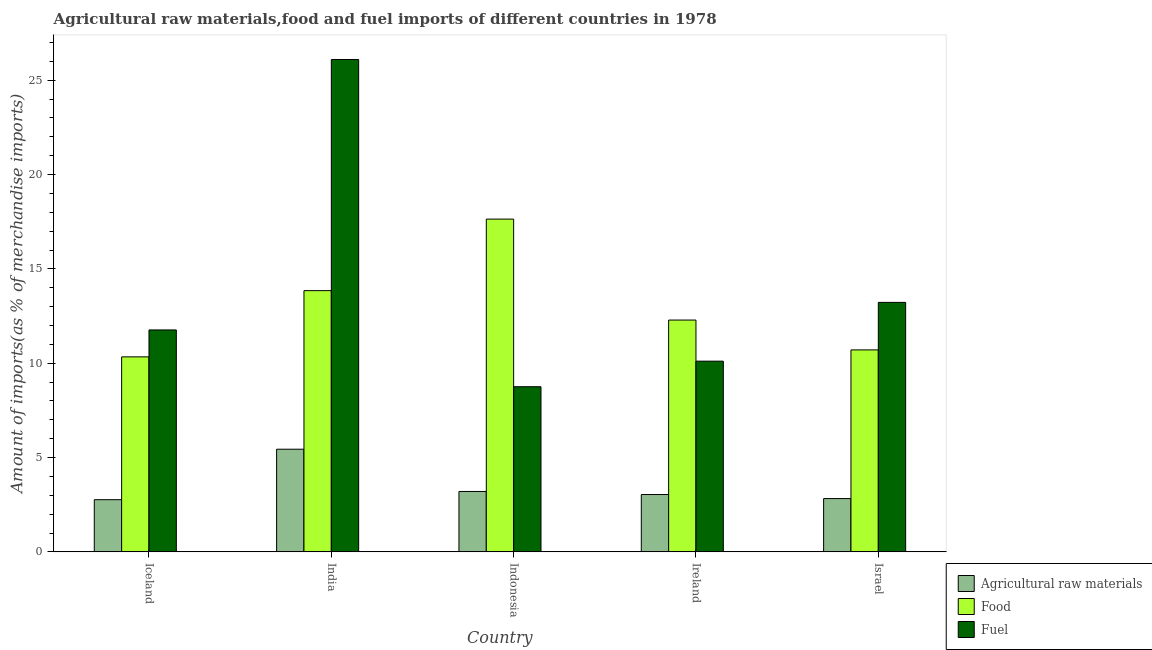Are the number of bars per tick equal to the number of legend labels?
Your answer should be very brief. Yes. Are the number of bars on each tick of the X-axis equal?
Keep it short and to the point. Yes. How many bars are there on the 5th tick from the left?
Provide a short and direct response. 3. How many bars are there on the 1st tick from the right?
Ensure brevity in your answer.  3. What is the label of the 4th group of bars from the left?
Ensure brevity in your answer.  Ireland. In how many cases, is the number of bars for a given country not equal to the number of legend labels?
Keep it short and to the point. 0. What is the percentage of food imports in India?
Offer a very short reply. 13.85. Across all countries, what is the maximum percentage of raw materials imports?
Make the answer very short. 5.44. Across all countries, what is the minimum percentage of fuel imports?
Make the answer very short. 8.75. What is the total percentage of food imports in the graph?
Give a very brief answer. 64.81. What is the difference between the percentage of fuel imports in India and that in Ireland?
Provide a succinct answer. 15.99. What is the difference between the percentage of raw materials imports in Iceland and the percentage of fuel imports in Ireland?
Your answer should be very brief. -7.34. What is the average percentage of food imports per country?
Offer a very short reply. 12.96. What is the difference between the percentage of raw materials imports and percentage of food imports in Iceland?
Provide a succinct answer. -7.57. In how many countries, is the percentage of raw materials imports greater than 10 %?
Offer a terse response. 0. What is the ratio of the percentage of raw materials imports in India to that in Israel?
Your response must be concise. 1.93. Is the percentage of fuel imports in Iceland less than that in India?
Provide a short and direct response. Yes. Is the difference between the percentage of fuel imports in India and Israel greater than the difference between the percentage of raw materials imports in India and Israel?
Give a very brief answer. Yes. What is the difference between the highest and the second highest percentage of fuel imports?
Offer a terse response. 12.87. What is the difference between the highest and the lowest percentage of raw materials imports?
Provide a succinct answer. 2.68. In how many countries, is the percentage of fuel imports greater than the average percentage of fuel imports taken over all countries?
Your answer should be very brief. 1. Is the sum of the percentage of fuel imports in Iceland and Israel greater than the maximum percentage of food imports across all countries?
Offer a very short reply. Yes. What does the 1st bar from the left in Indonesia represents?
Give a very brief answer. Agricultural raw materials. What does the 3rd bar from the right in India represents?
Give a very brief answer. Agricultural raw materials. Are all the bars in the graph horizontal?
Your answer should be compact. No. How many countries are there in the graph?
Offer a very short reply. 5. What is the difference between two consecutive major ticks on the Y-axis?
Your answer should be very brief. 5. Are the values on the major ticks of Y-axis written in scientific E-notation?
Your answer should be very brief. No. Does the graph contain any zero values?
Your response must be concise. No. Does the graph contain grids?
Your answer should be very brief. No. How many legend labels are there?
Provide a succinct answer. 3. What is the title of the graph?
Ensure brevity in your answer.  Agricultural raw materials,food and fuel imports of different countries in 1978. What is the label or title of the Y-axis?
Provide a succinct answer. Amount of imports(as % of merchandise imports). What is the Amount of imports(as % of merchandise imports) of Agricultural raw materials in Iceland?
Offer a terse response. 2.77. What is the Amount of imports(as % of merchandise imports) of Food in Iceland?
Make the answer very short. 10.34. What is the Amount of imports(as % of merchandise imports) in Fuel in Iceland?
Your response must be concise. 11.76. What is the Amount of imports(as % of merchandise imports) in Agricultural raw materials in India?
Provide a succinct answer. 5.44. What is the Amount of imports(as % of merchandise imports) of Food in India?
Keep it short and to the point. 13.85. What is the Amount of imports(as % of merchandise imports) in Fuel in India?
Offer a very short reply. 26.1. What is the Amount of imports(as % of merchandise imports) of Agricultural raw materials in Indonesia?
Your response must be concise. 3.2. What is the Amount of imports(as % of merchandise imports) in Food in Indonesia?
Offer a very short reply. 17.64. What is the Amount of imports(as % of merchandise imports) in Fuel in Indonesia?
Offer a terse response. 8.75. What is the Amount of imports(as % of merchandise imports) in Agricultural raw materials in Ireland?
Keep it short and to the point. 3.04. What is the Amount of imports(as % of merchandise imports) in Food in Ireland?
Provide a succinct answer. 12.29. What is the Amount of imports(as % of merchandise imports) of Fuel in Ireland?
Provide a short and direct response. 10.11. What is the Amount of imports(as % of merchandise imports) in Agricultural raw materials in Israel?
Provide a succinct answer. 2.82. What is the Amount of imports(as % of merchandise imports) of Food in Israel?
Keep it short and to the point. 10.71. What is the Amount of imports(as % of merchandise imports) in Fuel in Israel?
Ensure brevity in your answer.  13.22. Across all countries, what is the maximum Amount of imports(as % of merchandise imports) in Agricultural raw materials?
Provide a short and direct response. 5.44. Across all countries, what is the maximum Amount of imports(as % of merchandise imports) of Food?
Ensure brevity in your answer.  17.64. Across all countries, what is the maximum Amount of imports(as % of merchandise imports) in Fuel?
Keep it short and to the point. 26.1. Across all countries, what is the minimum Amount of imports(as % of merchandise imports) in Agricultural raw materials?
Offer a terse response. 2.77. Across all countries, what is the minimum Amount of imports(as % of merchandise imports) of Food?
Keep it short and to the point. 10.34. Across all countries, what is the minimum Amount of imports(as % of merchandise imports) of Fuel?
Give a very brief answer. 8.75. What is the total Amount of imports(as % of merchandise imports) in Agricultural raw materials in the graph?
Ensure brevity in your answer.  17.27. What is the total Amount of imports(as % of merchandise imports) of Food in the graph?
Offer a terse response. 64.81. What is the total Amount of imports(as % of merchandise imports) in Fuel in the graph?
Make the answer very short. 69.95. What is the difference between the Amount of imports(as % of merchandise imports) in Agricultural raw materials in Iceland and that in India?
Make the answer very short. -2.68. What is the difference between the Amount of imports(as % of merchandise imports) in Food in Iceland and that in India?
Provide a succinct answer. -3.51. What is the difference between the Amount of imports(as % of merchandise imports) of Fuel in Iceland and that in India?
Offer a very short reply. -14.33. What is the difference between the Amount of imports(as % of merchandise imports) in Agricultural raw materials in Iceland and that in Indonesia?
Your answer should be very brief. -0.44. What is the difference between the Amount of imports(as % of merchandise imports) of Food in Iceland and that in Indonesia?
Your response must be concise. -7.3. What is the difference between the Amount of imports(as % of merchandise imports) in Fuel in Iceland and that in Indonesia?
Your answer should be very brief. 3.01. What is the difference between the Amount of imports(as % of merchandise imports) in Agricultural raw materials in Iceland and that in Ireland?
Give a very brief answer. -0.27. What is the difference between the Amount of imports(as % of merchandise imports) of Food in Iceland and that in Ireland?
Give a very brief answer. -1.95. What is the difference between the Amount of imports(as % of merchandise imports) of Fuel in Iceland and that in Ireland?
Ensure brevity in your answer.  1.66. What is the difference between the Amount of imports(as % of merchandise imports) of Agricultural raw materials in Iceland and that in Israel?
Your response must be concise. -0.06. What is the difference between the Amount of imports(as % of merchandise imports) of Food in Iceland and that in Israel?
Ensure brevity in your answer.  -0.37. What is the difference between the Amount of imports(as % of merchandise imports) of Fuel in Iceland and that in Israel?
Your response must be concise. -1.46. What is the difference between the Amount of imports(as % of merchandise imports) in Agricultural raw materials in India and that in Indonesia?
Give a very brief answer. 2.24. What is the difference between the Amount of imports(as % of merchandise imports) of Food in India and that in Indonesia?
Make the answer very short. -3.79. What is the difference between the Amount of imports(as % of merchandise imports) of Fuel in India and that in Indonesia?
Provide a short and direct response. 17.34. What is the difference between the Amount of imports(as % of merchandise imports) in Agricultural raw materials in India and that in Ireland?
Keep it short and to the point. 2.4. What is the difference between the Amount of imports(as % of merchandise imports) of Food in India and that in Ireland?
Give a very brief answer. 1.56. What is the difference between the Amount of imports(as % of merchandise imports) of Fuel in India and that in Ireland?
Provide a succinct answer. 15.99. What is the difference between the Amount of imports(as % of merchandise imports) in Agricultural raw materials in India and that in Israel?
Ensure brevity in your answer.  2.62. What is the difference between the Amount of imports(as % of merchandise imports) in Food in India and that in Israel?
Provide a short and direct response. 3.14. What is the difference between the Amount of imports(as % of merchandise imports) in Fuel in India and that in Israel?
Ensure brevity in your answer.  12.87. What is the difference between the Amount of imports(as % of merchandise imports) of Agricultural raw materials in Indonesia and that in Ireland?
Give a very brief answer. 0.16. What is the difference between the Amount of imports(as % of merchandise imports) in Food in Indonesia and that in Ireland?
Offer a terse response. 5.35. What is the difference between the Amount of imports(as % of merchandise imports) of Fuel in Indonesia and that in Ireland?
Make the answer very short. -1.35. What is the difference between the Amount of imports(as % of merchandise imports) in Agricultural raw materials in Indonesia and that in Israel?
Make the answer very short. 0.38. What is the difference between the Amount of imports(as % of merchandise imports) in Food in Indonesia and that in Israel?
Give a very brief answer. 6.93. What is the difference between the Amount of imports(as % of merchandise imports) in Fuel in Indonesia and that in Israel?
Your response must be concise. -4.47. What is the difference between the Amount of imports(as % of merchandise imports) of Agricultural raw materials in Ireland and that in Israel?
Provide a short and direct response. 0.22. What is the difference between the Amount of imports(as % of merchandise imports) in Food in Ireland and that in Israel?
Ensure brevity in your answer.  1.58. What is the difference between the Amount of imports(as % of merchandise imports) in Fuel in Ireland and that in Israel?
Offer a terse response. -3.12. What is the difference between the Amount of imports(as % of merchandise imports) in Agricultural raw materials in Iceland and the Amount of imports(as % of merchandise imports) in Food in India?
Your answer should be very brief. -11.08. What is the difference between the Amount of imports(as % of merchandise imports) of Agricultural raw materials in Iceland and the Amount of imports(as % of merchandise imports) of Fuel in India?
Offer a very short reply. -23.33. What is the difference between the Amount of imports(as % of merchandise imports) of Food in Iceland and the Amount of imports(as % of merchandise imports) of Fuel in India?
Your response must be concise. -15.76. What is the difference between the Amount of imports(as % of merchandise imports) in Agricultural raw materials in Iceland and the Amount of imports(as % of merchandise imports) in Food in Indonesia?
Ensure brevity in your answer.  -14.87. What is the difference between the Amount of imports(as % of merchandise imports) in Agricultural raw materials in Iceland and the Amount of imports(as % of merchandise imports) in Fuel in Indonesia?
Your response must be concise. -5.99. What is the difference between the Amount of imports(as % of merchandise imports) in Food in Iceland and the Amount of imports(as % of merchandise imports) in Fuel in Indonesia?
Your answer should be compact. 1.58. What is the difference between the Amount of imports(as % of merchandise imports) in Agricultural raw materials in Iceland and the Amount of imports(as % of merchandise imports) in Food in Ireland?
Your answer should be very brief. -9.52. What is the difference between the Amount of imports(as % of merchandise imports) of Agricultural raw materials in Iceland and the Amount of imports(as % of merchandise imports) of Fuel in Ireland?
Keep it short and to the point. -7.34. What is the difference between the Amount of imports(as % of merchandise imports) in Food in Iceland and the Amount of imports(as % of merchandise imports) in Fuel in Ireland?
Make the answer very short. 0.23. What is the difference between the Amount of imports(as % of merchandise imports) in Agricultural raw materials in Iceland and the Amount of imports(as % of merchandise imports) in Food in Israel?
Make the answer very short. -7.94. What is the difference between the Amount of imports(as % of merchandise imports) of Agricultural raw materials in Iceland and the Amount of imports(as % of merchandise imports) of Fuel in Israel?
Ensure brevity in your answer.  -10.46. What is the difference between the Amount of imports(as % of merchandise imports) in Food in Iceland and the Amount of imports(as % of merchandise imports) in Fuel in Israel?
Keep it short and to the point. -2.89. What is the difference between the Amount of imports(as % of merchandise imports) in Agricultural raw materials in India and the Amount of imports(as % of merchandise imports) in Food in Indonesia?
Offer a very short reply. -12.2. What is the difference between the Amount of imports(as % of merchandise imports) in Agricultural raw materials in India and the Amount of imports(as % of merchandise imports) in Fuel in Indonesia?
Make the answer very short. -3.31. What is the difference between the Amount of imports(as % of merchandise imports) in Food in India and the Amount of imports(as % of merchandise imports) in Fuel in Indonesia?
Your response must be concise. 5.09. What is the difference between the Amount of imports(as % of merchandise imports) in Agricultural raw materials in India and the Amount of imports(as % of merchandise imports) in Food in Ireland?
Your answer should be very brief. -6.85. What is the difference between the Amount of imports(as % of merchandise imports) of Agricultural raw materials in India and the Amount of imports(as % of merchandise imports) of Fuel in Ireland?
Provide a short and direct response. -4.67. What is the difference between the Amount of imports(as % of merchandise imports) in Food in India and the Amount of imports(as % of merchandise imports) in Fuel in Ireland?
Offer a terse response. 3.74. What is the difference between the Amount of imports(as % of merchandise imports) in Agricultural raw materials in India and the Amount of imports(as % of merchandise imports) in Food in Israel?
Provide a short and direct response. -5.26. What is the difference between the Amount of imports(as % of merchandise imports) in Agricultural raw materials in India and the Amount of imports(as % of merchandise imports) in Fuel in Israel?
Keep it short and to the point. -7.78. What is the difference between the Amount of imports(as % of merchandise imports) of Food in India and the Amount of imports(as % of merchandise imports) of Fuel in Israel?
Provide a short and direct response. 0.62. What is the difference between the Amount of imports(as % of merchandise imports) of Agricultural raw materials in Indonesia and the Amount of imports(as % of merchandise imports) of Food in Ireland?
Provide a short and direct response. -9.08. What is the difference between the Amount of imports(as % of merchandise imports) in Agricultural raw materials in Indonesia and the Amount of imports(as % of merchandise imports) in Fuel in Ireland?
Keep it short and to the point. -6.91. What is the difference between the Amount of imports(as % of merchandise imports) in Food in Indonesia and the Amount of imports(as % of merchandise imports) in Fuel in Ireland?
Your answer should be compact. 7.53. What is the difference between the Amount of imports(as % of merchandise imports) in Agricultural raw materials in Indonesia and the Amount of imports(as % of merchandise imports) in Food in Israel?
Offer a terse response. -7.5. What is the difference between the Amount of imports(as % of merchandise imports) in Agricultural raw materials in Indonesia and the Amount of imports(as % of merchandise imports) in Fuel in Israel?
Provide a succinct answer. -10.02. What is the difference between the Amount of imports(as % of merchandise imports) in Food in Indonesia and the Amount of imports(as % of merchandise imports) in Fuel in Israel?
Keep it short and to the point. 4.41. What is the difference between the Amount of imports(as % of merchandise imports) in Agricultural raw materials in Ireland and the Amount of imports(as % of merchandise imports) in Food in Israel?
Offer a terse response. -7.67. What is the difference between the Amount of imports(as % of merchandise imports) of Agricultural raw materials in Ireland and the Amount of imports(as % of merchandise imports) of Fuel in Israel?
Make the answer very short. -10.18. What is the difference between the Amount of imports(as % of merchandise imports) of Food in Ireland and the Amount of imports(as % of merchandise imports) of Fuel in Israel?
Your answer should be very brief. -0.94. What is the average Amount of imports(as % of merchandise imports) of Agricultural raw materials per country?
Your answer should be very brief. 3.45. What is the average Amount of imports(as % of merchandise imports) of Food per country?
Give a very brief answer. 12.96. What is the average Amount of imports(as % of merchandise imports) of Fuel per country?
Provide a succinct answer. 13.99. What is the difference between the Amount of imports(as % of merchandise imports) in Agricultural raw materials and Amount of imports(as % of merchandise imports) in Food in Iceland?
Your answer should be compact. -7.57. What is the difference between the Amount of imports(as % of merchandise imports) in Agricultural raw materials and Amount of imports(as % of merchandise imports) in Fuel in Iceland?
Offer a very short reply. -9. What is the difference between the Amount of imports(as % of merchandise imports) of Food and Amount of imports(as % of merchandise imports) of Fuel in Iceland?
Your response must be concise. -1.43. What is the difference between the Amount of imports(as % of merchandise imports) in Agricultural raw materials and Amount of imports(as % of merchandise imports) in Food in India?
Offer a terse response. -8.41. What is the difference between the Amount of imports(as % of merchandise imports) in Agricultural raw materials and Amount of imports(as % of merchandise imports) in Fuel in India?
Your answer should be very brief. -20.66. What is the difference between the Amount of imports(as % of merchandise imports) of Food and Amount of imports(as % of merchandise imports) of Fuel in India?
Provide a short and direct response. -12.25. What is the difference between the Amount of imports(as % of merchandise imports) of Agricultural raw materials and Amount of imports(as % of merchandise imports) of Food in Indonesia?
Offer a terse response. -14.44. What is the difference between the Amount of imports(as % of merchandise imports) of Agricultural raw materials and Amount of imports(as % of merchandise imports) of Fuel in Indonesia?
Your answer should be very brief. -5.55. What is the difference between the Amount of imports(as % of merchandise imports) in Food and Amount of imports(as % of merchandise imports) in Fuel in Indonesia?
Your answer should be compact. 8.88. What is the difference between the Amount of imports(as % of merchandise imports) in Agricultural raw materials and Amount of imports(as % of merchandise imports) in Food in Ireland?
Provide a short and direct response. -9.25. What is the difference between the Amount of imports(as % of merchandise imports) in Agricultural raw materials and Amount of imports(as % of merchandise imports) in Fuel in Ireland?
Your answer should be compact. -7.07. What is the difference between the Amount of imports(as % of merchandise imports) in Food and Amount of imports(as % of merchandise imports) in Fuel in Ireland?
Provide a short and direct response. 2.18. What is the difference between the Amount of imports(as % of merchandise imports) in Agricultural raw materials and Amount of imports(as % of merchandise imports) in Food in Israel?
Your answer should be very brief. -7.88. What is the difference between the Amount of imports(as % of merchandise imports) of Agricultural raw materials and Amount of imports(as % of merchandise imports) of Fuel in Israel?
Your answer should be compact. -10.4. What is the difference between the Amount of imports(as % of merchandise imports) in Food and Amount of imports(as % of merchandise imports) in Fuel in Israel?
Ensure brevity in your answer.  -2.52. What is the ratio of the Amount of imports(as % of merchandise imports) in Agricultural raw materials in Iceland to that in India?
Provide a short and direct response. 0.51. What is the ratio of the Amount of imports(as % of merchandise imports) of Food in Iceland to that in India?
Offer a terse response. 0.75. What is the ratio of the Amount of imports(as % of merchandise imports) of Fuel in Iceland to that in India?
Make the answer very short. 0.45. What is the ratio of the Amount of imports(as % of merchandise imports) of Agricultural raw materials in Iceland to that in Indonesia?
Keep it short and to the point. 0.86. What is the ratio of the Amount of imports(as % of merchandise imports) in Food in Iceland to that in Indonesia?
Offer a terse response. 0.59. What is the ratio of the Amount of imports(as % of merchandise imports) in Fuel in Iceland to that in Indonesia?
Ensure brevity in your answer.  1.34. What is the ratio of the Amount of imports(as % of merchandise imports) of Agricultural raw materials in Iceland to that in Ireland?
Your answer should be very brief. 0.91. What is the ratio of the Amount of imports(as % of merchandise imports) in Food in Iceland to that in Ireland?
Provide a succinct answer. 0.84. What is the ratio of the Amount of imports(as % of merchandise imports) in Fuel in Iceland to that in Ireland?
Make the answer very short. 1.16. What is the ratio of the Amount of imports(as % of merchandise imports) of Agricultural raw materials in Iceland to that in Israel?
Provide a short and direct response. 0.98. What is the ratio of the Amount of imports(as % of merchandise imports) of Food in Iceland to that in Israel?
Offer a terse response. 0.97. What is the ratio of the Amount of imports(as % of merchandise imports) of Fuel in Iceland to that in Israel?
Your answer should be very brief. 0.89. What is the ratio of the Amount of imports(as % of merchandise imports) of Agricultural raw materials in India to that in Indonesia?
Provide a succinct answer. 1.7. What is the ratio of the Amount of imports(as % of merchandise imports) in Food in India to that in Indonesia?
Offer a very short reply. 0.79. What is the ratio of the Amount of imports(as % of merchandise imports) of Fuel in India to that in Indonesia?
Your response must be concise. 2.98. What is the ratio of the Amount of imports(as % of merchandise imports) of Agricultural raw materials in India to that in Ireland?
Provide a short and direct response. 1.79. What is the ratio of the Amount of imports(as % of merchandise imports) of Food in India to that in Ireland?
Keep it short and to the point. 1.13. What is the ratio of the Amount of imports(as % of merchandise imports) in Fuel in India to that in Ireland?
Provide a succinct answer. 2.58. What is the ratio of the Amount of imports(as % of merchandise imports) in Agricultural raw materials in India to that in Israel?
Make the answer very short. 1.93. What is the ratio of the Amount of imports(as % of merchandise imports) of Food in India to that in Israel?
Offer a very short reply. 1.29. What is the ratio of the Amount of imports(as % of merchandise imports) of Fuel in India to that in Israel?
Provide a short and direct response. 1.97. What is the ratio of the Amount of imports(as % of merchandise imports) of Agricultural raw materials in Indonesia to that in Ireland?
Your answer should be very brief. 1.05. What is the ratio of the Amount of imports(as % of merchandise imports) in Food in Indonesia to that in Ireland?
Your response must be concise. 1.44. What is the ratio of the Amount of imports(as % of merchandise imports) of Fuel in Indonesia to that in Ireland?
Offer a very short reply. 0.87. What is the ratio of the Amount of imports(as % of merchandise imports) in Agricultural raw materials in Indonesia to that in Israel?
Offer a terse response. 1.13. What is the ratio of the Amount of imports(as % of merchandise imports) of Food in Indonesia to that in Israel?
Your answer should be compact. 1.65. What is the ratio of the Amount of imports(as % of merchandise imports) of Fuel in Indonesia to that in Israel?
Your answer should be very brief. 0.66. What is the ratio of the Amount of imports(as % of merchandise imports) in Agricultural raw materials in Ireland to that in Israel?
Keep it short and to the point. 1.08. What is the ratio of the Amount of imports(as % of merchandise imports) in Food in Ireland to that in Israel?
Your response must be concise. 1.15. What is the ratio of the Amount of imports(as % of merchandise imports) of Fuel in Ireland to that in Israel?
Provide a succinct answer. 0.76. What is the difference between the highest and the second highest Amount of imports(as % of merchandise imports) of Agricultural raw materials?
Offer a very short reply. 2.24. What is the difference between the highest and the second highest Amount of imports(as % of merchandise imports) in Food?
Keep it short and to the point. 3.79. What is the difference between the highest and the second highest Amount of imports(as % of merchandise imports) of Fuel?
Make the answer very short. 12.87. What is the difference between the highest and the lowest Amount of imports(as % of merchandise imports) of Agricultural raw materials?
Provide a succinct answer. 2.68. What is the difference between the highest and the lowest Amount of imports(as % of merchandise imports) in Food?
Offer a very short reply. 7.3. What is the difference between the highest and the lowest Amount of imports(as % of merchandise imports) in Fuel?
Keep it short and to the point. 17.34. 